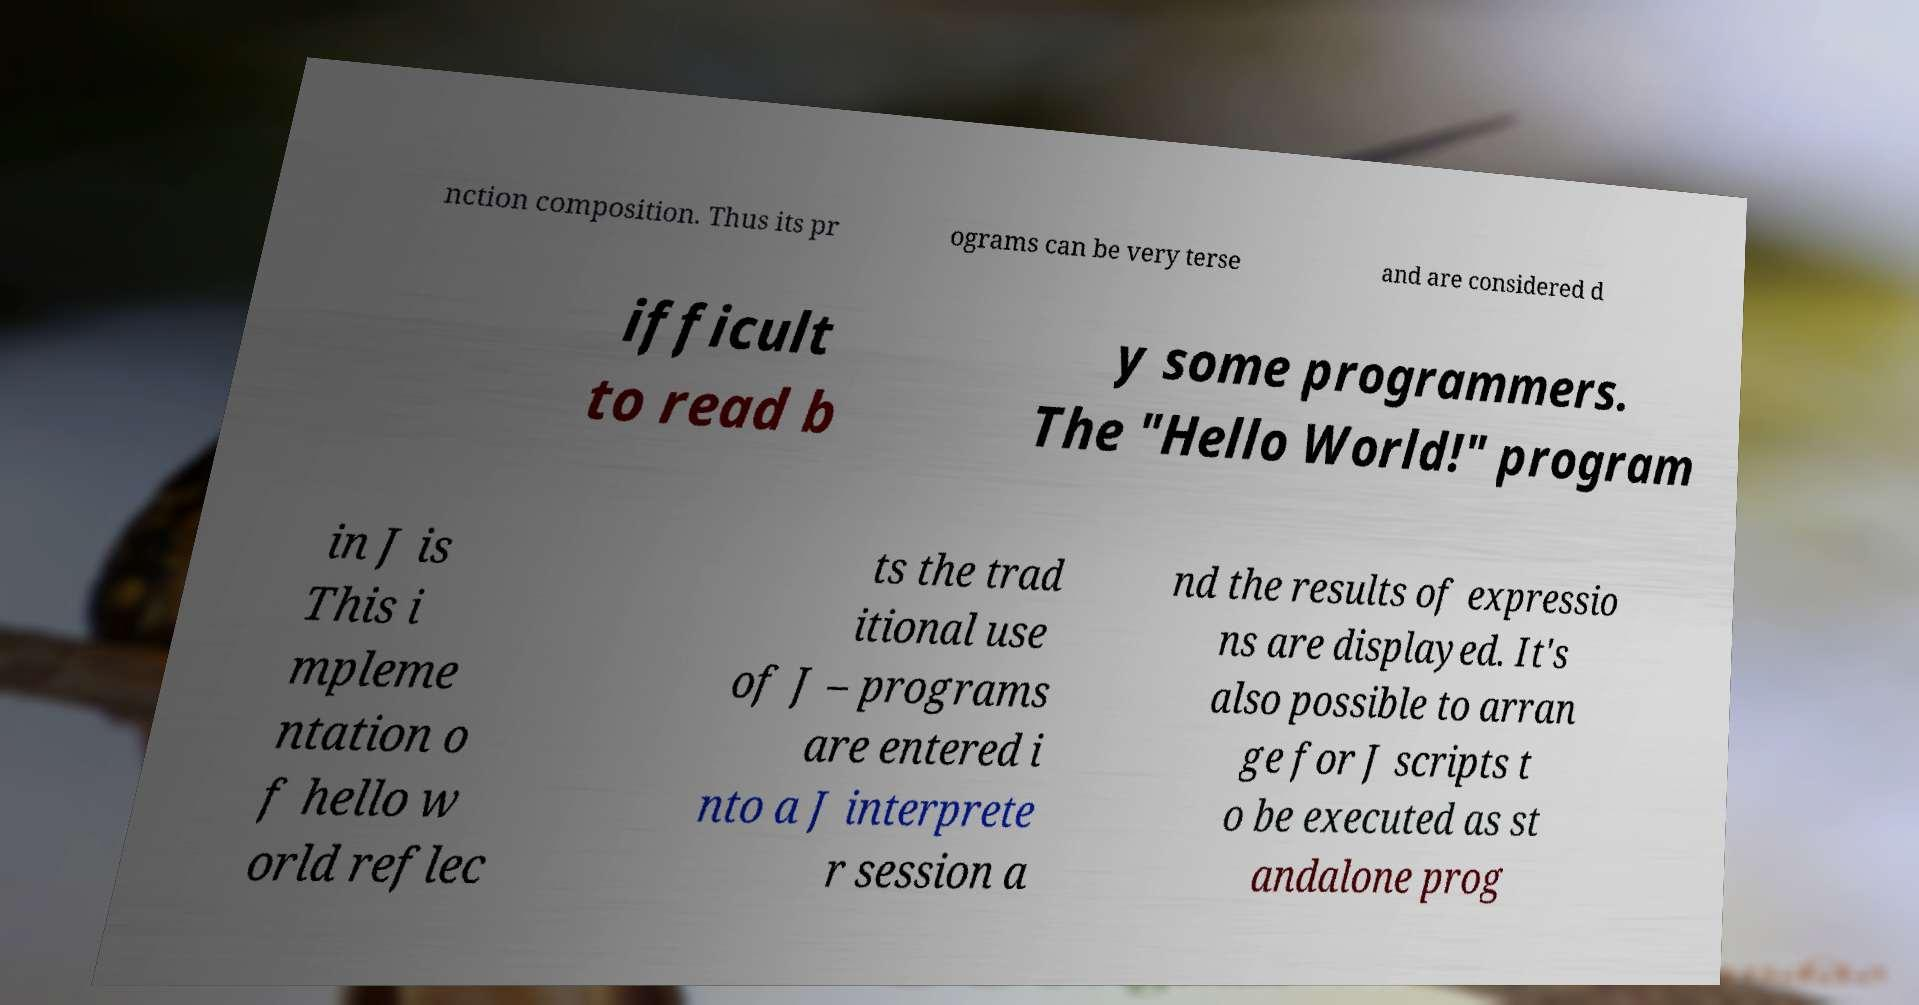Please read and relay the text visible in this image. What does it say? nction composition. Thus its pr ograms can be very terse and are considered d ifficult to read b y some programmers. The "Hello World!" program in J is This i mpleme ntation o f hello w orld reflec ts the trad itional use of J – programs are entered i nto a J interprete r session a nd the results of expressio ns are displayed. It's also possible to arran ge for J scripts t o be executed as st andalone prog 